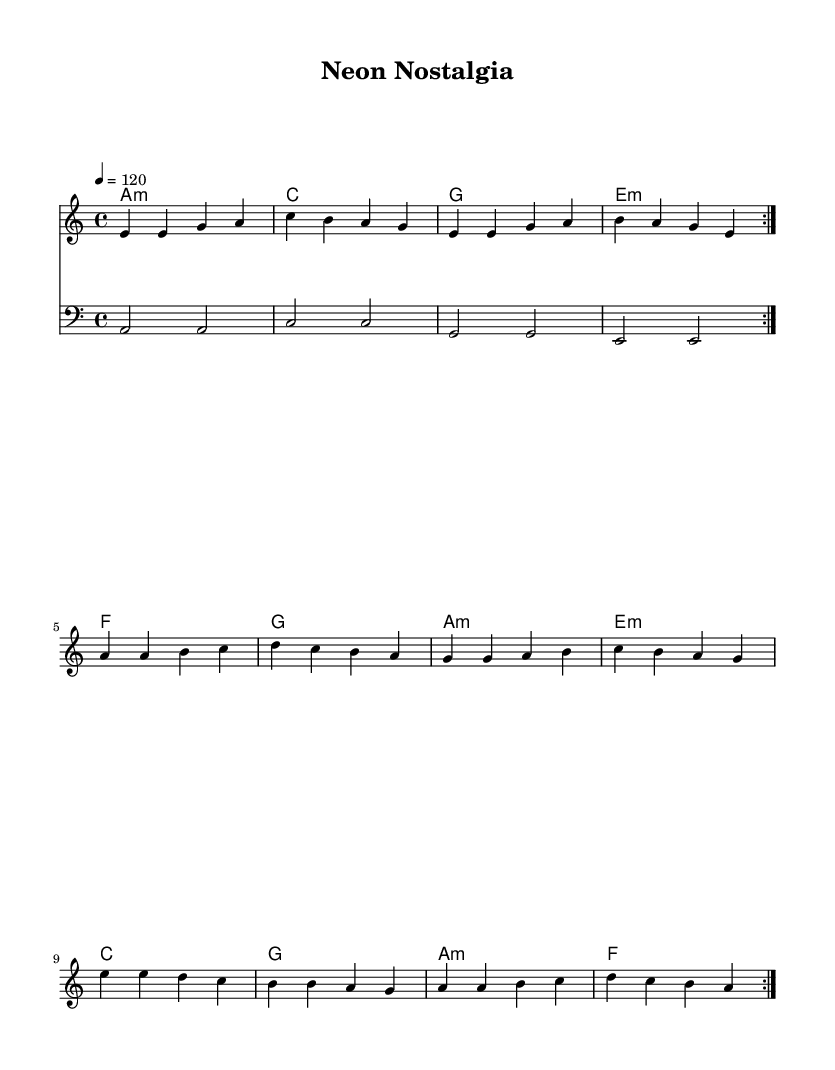What is the key signature of this music? The key signature is indicated by the presence of only one flat or the absence of sharps, which shows that the piece is in A minor.
Answer: A minor What is the time signature of this piece? The time signature is located at the beginning of the staff and indicates that there are four beats per measure, represented by the notation 4/4.
Answer: 4/4 What is the tempo marking for this composition? The tempo is specified at the beginning of the score, which indicates a speed of 120 beats per minute, noted as 4 = 120.
Answer: 120 How many measures are repeated in the melody? The notation shows a repeat sign (volta) after the first part of the melody suggesting that this section is played twice, leading to a total of 16 measures when repeated.
Answer: 16 What type of chord is used at the start of the harmony section? The first chord name indicates it is an A minor chord, which is represented with the notation "a1:m".
Answer: A minor What genre does this piece predominantly represent? The characteristics of catchy melodies and retro-futuristic production clearly categorize this piece within the electronic genre, particularly indie electronic pop.
Answer: Indie electronic pop 